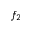<formula> <loc_0><loc_0><loc_500><loc_500>f _ { 2 }</formula> 